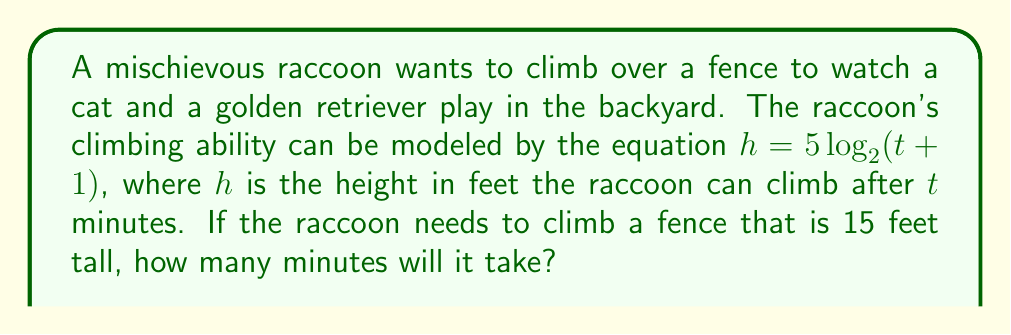Can you answer this question? Let's approach this step-by-step:

1) We are given the equation $h = 5 \log_2(t + 1)$, where:
   $h$ = height in feet
   $t$ = time in minutes

2) We need to find $t$ when $h = 15$ feet (the height of the fence).

3) Let's substitute $h = 15$ into the equation:
   $15 = 5 \log_2(t + 1)$

4) Divide both sides by 5:
   $3 = \log_2(t + 1)$

5) To solve for $t$, we need to apply the inverse function (exponential) to both sides:
   $2^3 = t + 1$

6) Simplify:
   $8 = t + 1$

7) Subtract 1 from both sides:
   $7 = t$

Therefore, it will take the raccoon 7 minutes to climb the 15-foot fence.
Answer: $7$ minutes 